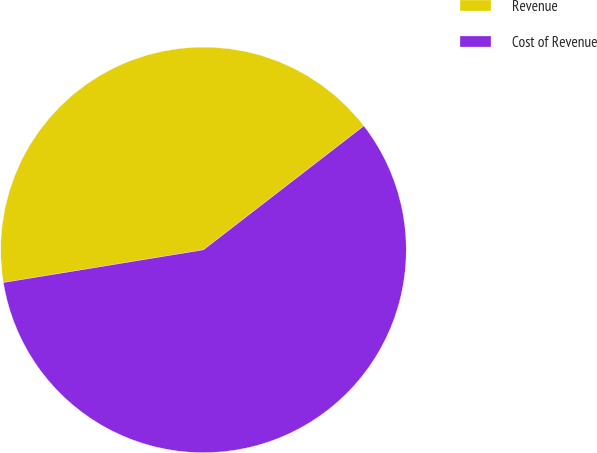Convert chart to OTSL. <chart><loc_0><loc_0><loc_500><loc_500><pie_chart><fcel>Revenue<fcel>Cost of Revenue<nl><fcel>42.11%<fcel>57.89%<nl></chart> 